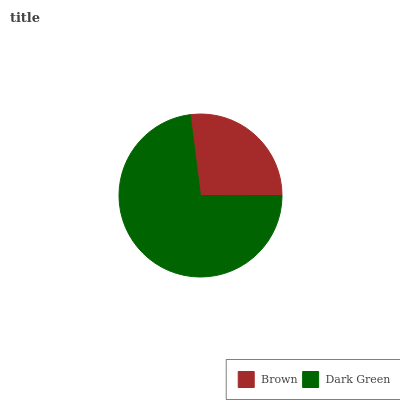Is Brown the minimum?
Answer yes or no. Yes. Is Dark Green the maximum?
Answer yes or no. Yes. Is Dark Green the minimum?
Answer yes or no. No. Is Dark Green greater than Brown?
Answer yes or no. Yes. Is Brown less than Dark Green?
Answer yes or no. Yes. Is Brown greater than Dark Green?
Answer yes or no. No. Is Dark Green less than Brown?
Answer yes or no. No. Is Dark Green the high median?
Answer yes or no. Yes. Is Brown the low median?
Answer yes or no. Yes. Is Brown the high median?
Answer yes or no. No. Is Dark Green the low median?
Answer yes or no. No. 